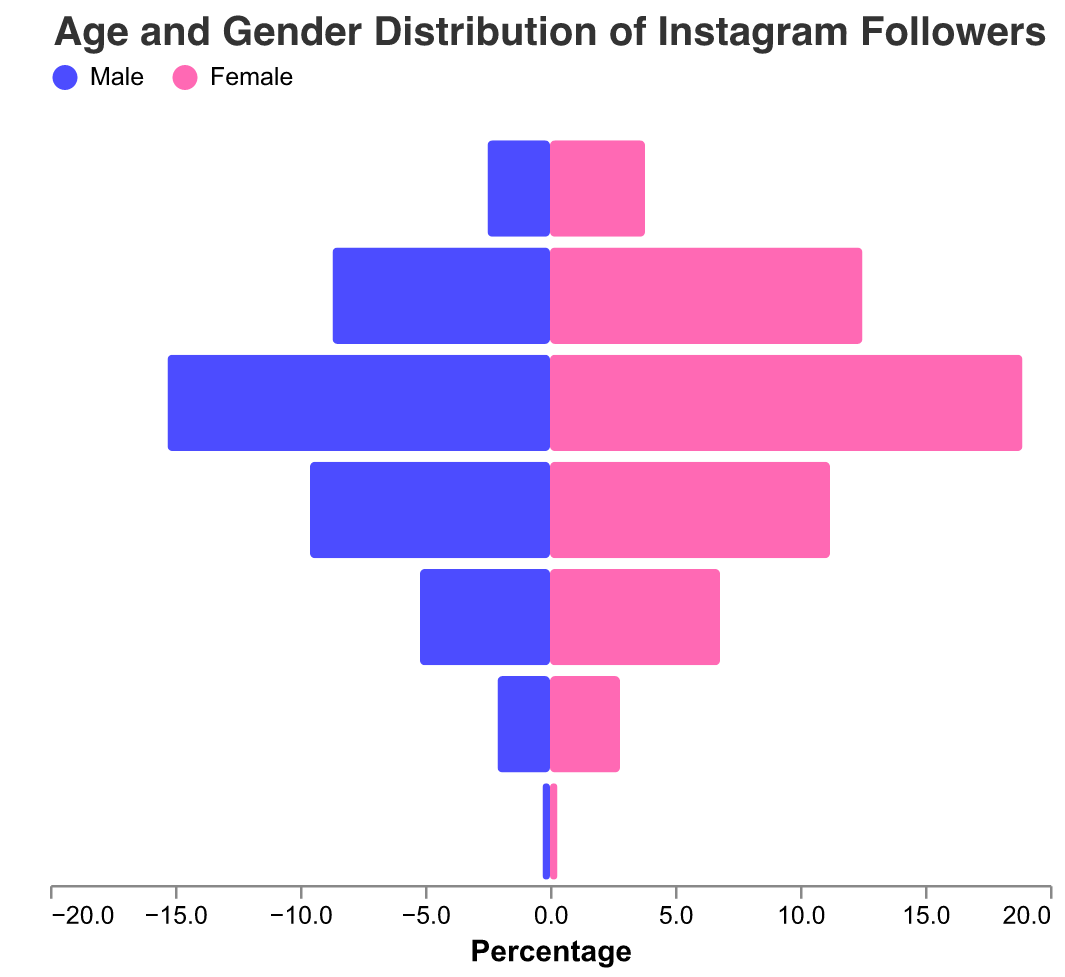Which age group has the highest percentage of male Instagram followers? From the figure, the highest percentage of male Instagram followers corresponds to the age group with the longest bar on the male side. The age group "25-34" has the highest value of 15.3%.
Answer: 25-34 Which age group has the lowest percentage of female Instagram followers? From the figure, the lowest percentage of female Instagram followers corresponds to the age group with the shortest bar on the female side. The age group "65+" has the lowest value of 0.3%.
Answer: 65+ What is the total percentage of Instagram followers aged 18-24? Add the percentages of male and female followers aged 18-24: 8.7% (Male) + 12.5% (Female) = 21.2%.
Answer: 21.2% How does the percentage of male followers aged 35-44 compare to female followers in the same age group? The figure shows 9.6% for male followers and 11.2% for female followers aged 35-44. The percentage of female followers is higher.
Answer: Female followers are higher What is the gender distribution for followers aged 45-54? From the figure, 5.2% of Instagram followers aged 45-54 are male, and 6.8% are female.
Answer: 5.2% Male, 6.8% Female Which gender has a higher following in the 13-17 age group? The figure shows that 3.8% of the followers in the 13-17 age group are female while 2.5% are male. Therefore, female followers are higher.
Answer: Female Is the percentage of followers aged 55-64 greater for males or females? The figure shows 2.1% male followers and 2.8% female followers aged 55-64. The percentage is greater for females.
Answer: Females What is the combined percentage of male followers for the age groups 45-54 and 55-64? Add the percentages of male followers in the age groups 45-54 and 55-64: 5.2% + 2.1% = 7.3%.
Answer: 7.3% Which age group has close to equal percentage of male and female followers? The figure shows that the age group "65+" has nearly equal percentages of male and female followers, both at 0.3%.
Answer: 65+ If we combine the percentage of followers in the two youngest age groups (13-17 and 18-24), which gender has a higher percentage? Combine the two youngest age groups: (2.5% + 8.7%) for males equals 11.2%, and (3.8% + 12.5%) for females equals 16.3%. Females have a higher percentage.
Answer: Females 